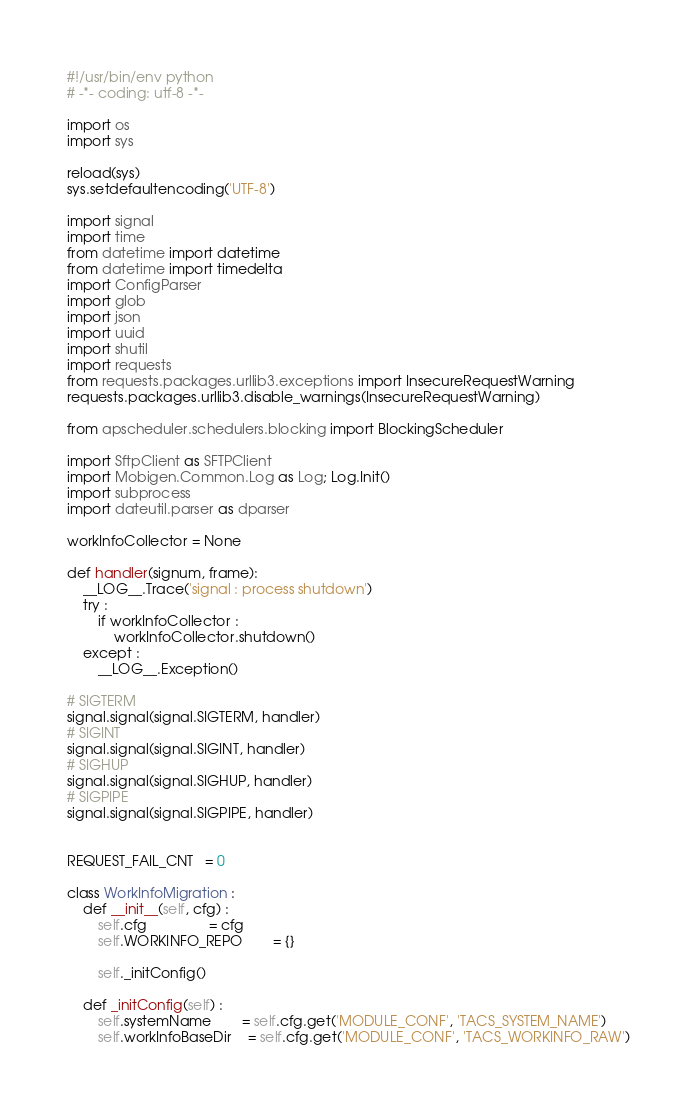Convert code to text. <code><loc_0><loc_0><loc_500><loc_500><_Python_>#!/usr/bin/env python
# -*- coding: utf-8 -*-

import os
import sys

reload(sys)
sys.setdefaultencoding('UTF-8')

import signal
import time
from datetime import datetime
from datetime import timedelta
import ConfigParser
import glob
import json
import uuid
import shutil
import requests
from requests.packages.urllib3.exceptions import InsecureRequestWarning
requests.packages.urllib3.disable_warnings(InsecureRequestWarning)

from apscheduler.schedulers.blocking import BlockingScheduler

import SftpClient as SFTPClient
import Mobigen.Common.Log as Log; Log.Init()
import subprocess
import dateutil.parser as dparser

workInfoCollector = None

def handler(signum, frame):
	__LOG__.Trace('signal : process shutdown')
	try :
		if workInfoCollector :
			workInfoCollector.shutdown()
	except : 
		__LOG__.Exception()

# SIGTERM
signal.signal(signal.SIGTERM, handler)
# SIGINT
signal.signal(signal.SIGINT, handler)
# SIGHUP
signal.signal(signal.SIGHUP, handler)
# SIGPIPE
signal.signal(signal.SIGPIPE, handler)


REQUEST_FAIL_CNT   = 0

class WorkInfoMigration :
	def __init__(self, cfg) :
		self.cfg 				= cfg
		self.WORKINFO_REPO 		= {}

		self._initConfig()

	def _initConfig(self) :
		self.systemName 		= self.cfg.get('MODULE_CONF', 'TACS_SYSTEM_NAME')
		self.workInfoBaseDir    = self.cfg.get('MODULE_CONF', 'TACS_WORKINFO_RAW')
</code> 